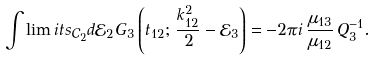Convert formula to latex. <formula><loc_0><loc_0><loc_500><loc_500>\int \lim i t s _ { \mathcal { C } _ { 2 } } d \mathcal { E } _ { 2 } { G } _ { 3 } \left ( t _ { 1 2 } ; \, \frac { k _ { 1 2 } ^ { 2 } } { 2 } - \mathcal { E } _ { 3 } \right ) = - 2 \pi i \, \frac { \mu _ { 1 3 } } { \mu _ { 1 2 } } \, { Q } _ { 3 } ^ { - 1 } .</formula> 